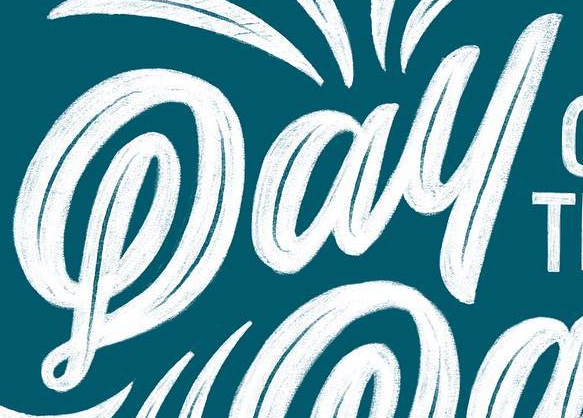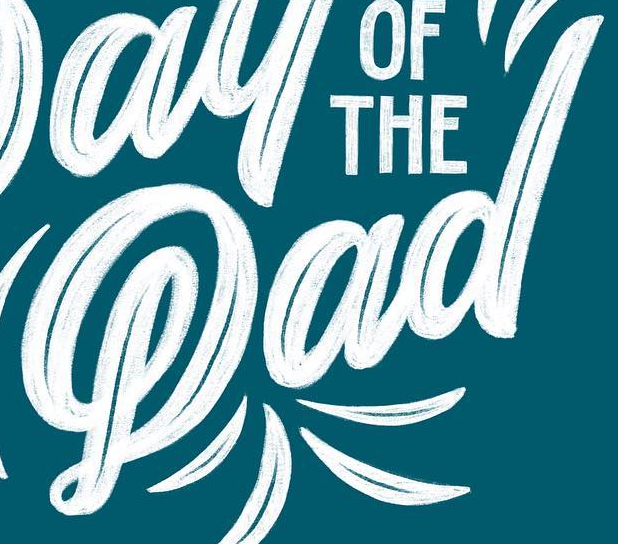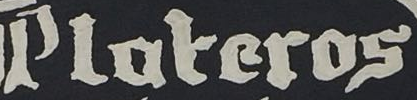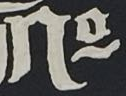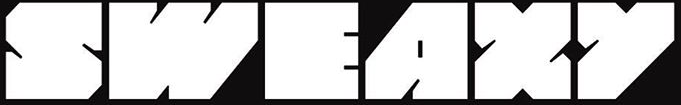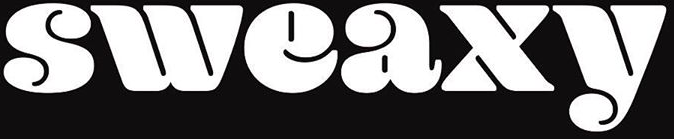What text appears in these images from left to right, separated by a semicolon? Pay; Pad; Ploteros; No; SWEAXY; sweaxy 